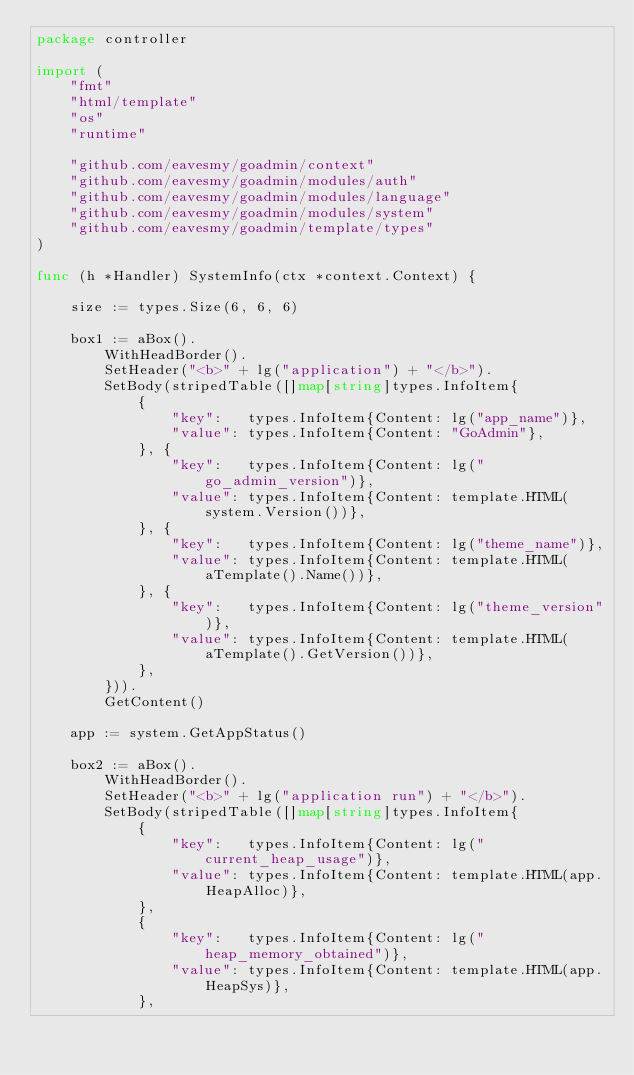<code> <loc_0><loc_0><loc_500><loc_500><_Go_>package controller

import (
	"fmt"
	"html/template"
	"os"
	"runtime"

	"github.com/eavesmy/goadmin/context"
	"github.com/eavesmy/goadmin/modules/auth"
	"github.com/eavesmy/goadmin/modules/language"
	"github.com/eavesmy/goadmin/modules/system"
	"github.com/eavesmy/goadmin/template/types"
)

func (h *Handler) SystemInfo(ctx *context.Context) {

	size := types.Size(6, 6, 6)

	box1 := aBox().
		WithHeadBorder().
		SetHeader("<b>" + lg("application") + "</b>").
		SetBody(stripedTable([]map[string]types.InfoItem{
			{
				"key":   types.InfoItem{Content: lg("app_name")},
				"value": types.InfoItem{Content: "GoAdmin"},
			}, {
				"key":   types.InfoItem{Content: lg("go_admin_version")},
				"value": types.InfoItem{Content: template.HTML(system.Version())},
			}, {
				"key":   types.InfoItem{Content: lg("theme_name")},
				"value": types.InfoItem{Content: template.HTML(aTemplate().Name())},
			}, {
				"key":   types.InfoItem{Content: lg("theme_version")},
				"value": types.InfoItem{Content: template.HTML(aTemplate().GetVersion())},
			},
		})).
		GetContent()

	app := system.GetAppStatus()

	box2 := aBox().
		WithHeadBorder().
		SetHeader("<b>" + lg("application run") + "</b>").
		SetBody(stripedTable([]map[string]types.InfoItem{
			{
				"key":   types.InfoItem{Content: lg("current_heap_usage")},
				"value": types.InfoItem{Content: template.HTML(app.HeapAlloc)},
			},
			{
				"key":   types.InfoItem{Content: lg("heap_memory_obtained")},
				"value": types.InfoItem{Content: template.HTML(app.HeapSys)},
			},</code> 